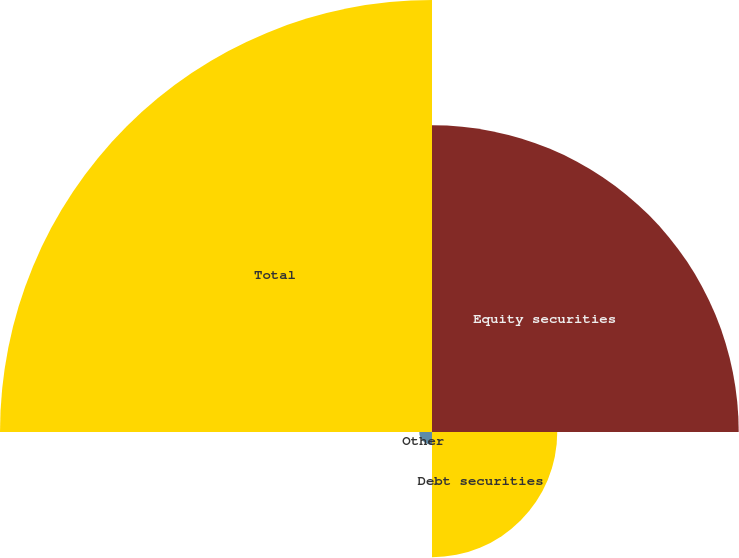<chart> <loc_0><loc_0><loc_500><loc_500><pie_chart><fcel>Equity securities<fcel>Debt securities<fcel>Other<fcel>Total<nl><fcel>34.99%<fcel>14.29%<fcel>1.45%<fcel>49.28%<nl></chart> 